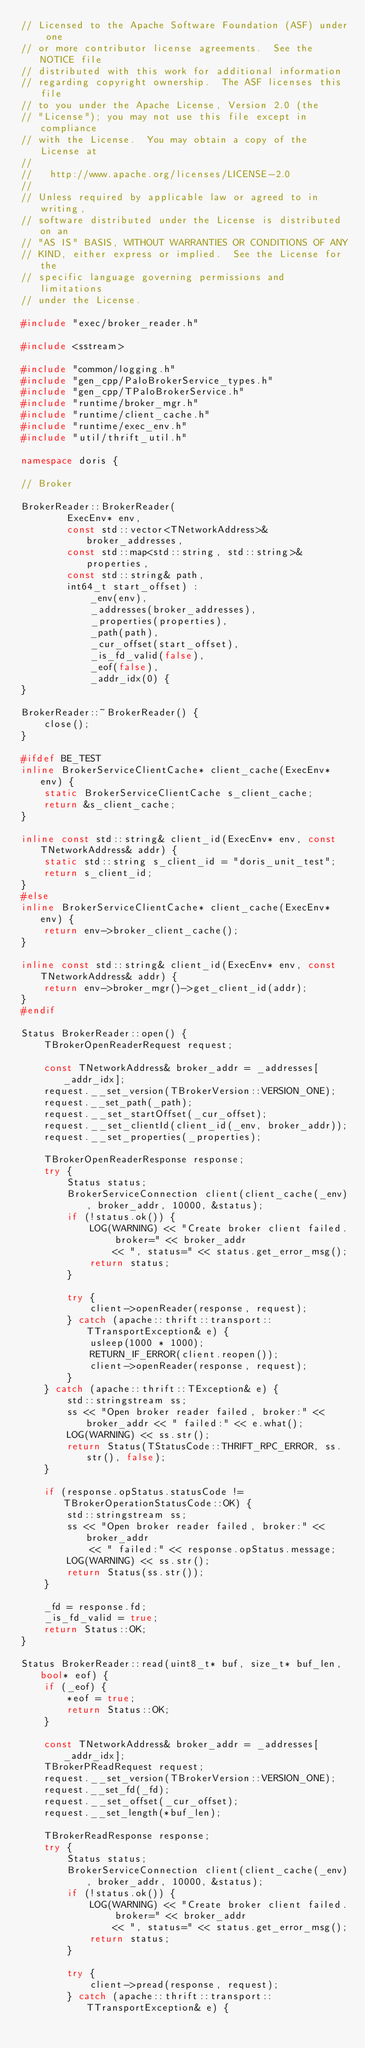Convert code to text. <code><loc_0><loc_0><loc_500><loc_500><_C++_>// Licensed to the Apache Software Foundation (ASF) under one
// or more contributor license agreements.  See the NOTICE file
// distributed with this work for additional information
// regarding copyright ownership.  The ASF licenses this file
// to you under the Apache License, Version 2.0 (the
// "License"); you may not use this file except in compliance
// with the License.  You may obtain a copy of the License at
//
//   http://www.apache.org/licenses/LICENSE-2.0
//
// Unless required by applicable law or agreed to in writing,
// software distributed under the License is distributed on an
// "AS IS" BASIS, WITHOUT WARRANTIES OR CONDITIONS OF ANY
// KIND, either express or implied.  See the License for the
// specific language governing permissions and limitations
// under the License.

#include "exec/broker_reader.h"

#include <sstream>

#include "common/logging.h"
#include "gen_cpp/PaloBrokerService_types.h"
#include "gen_cpp/TPaloBrokerService.h"
#include "runtime/broker_mgr.h"
#include "runtime/client_cache.h"
#include "runtime/exec_env.h"
#include "util/thrift_util.h"

namespace doris {

// Broker

BrokerReader::BrokerReader(
        ExecEnv* env,
        const std::vector<TNetworkAddress>& broker_addresses,
        const std::map<std::string, std::string>& properties,
        const std::string& path,
        int64_t start_offset) :
            _env(env),
            _addresses(broker_addresses),
            _properties(properties),
            _path(path),
            _cur_offset(start_offset),
            _is_fd_valid(false),
            _eof(false),
            _addr_idx(0) {
}

BrokerReader::~BrokerReader() {
    close();
}

#ifdef BE_TEST
inline BrokerServiceClientCache* client_cache(ExecEnv* env) {
    static BrokerServiceClientCache s_client_cache;
    return &s_client_cache;
}

inline const std::string& client_id(ExecEnv* env, const TNetworkAddress& addr) {
    static std::string s_client_id = "doris_unit_test";
    return s_client_id;
}
#else
inline BrokerServiceClientCache* client_cache(ExecEnv* env) {
    return env->broker_client_cache();
}

inline const std::string& client_id(ExecEnv* env, const TNetworkAddress& addr) {
    return env->broker_mgr()->get_client_id(addr);
}
#endif

Status BrokerReader::open() {
    TBrokerOpenReaderRequest request;

    const TNetworkAddress& broker_addr = _addresses[_addr_idx];
    request.__set_version(TBrokerVersion::VERSION_ONE);
    request.__set_path(_path);
    request.__set_startOffset(_cur_offset);
    request.__set_clientId(client_id(_env, broker_addr));
    request.__set_properties(_properties);

    TBrokerOpenReaderResponse response;
    try {
        Status status;
        BrokerServiceConnection client(client_cache(_env), broker_addr, 10000, &status);
        if (!status.ok()) {
            LOG(WARNING) << "Create broker client failed. broker=" << broker_addr
                << ", status=" << status.get_error_msg();
            return status;
        }

        try {
            client->openReader(response, request);
        } catch (apache::thrift::transport::TTransportException& e) {
            usleep(1000 * 1000);
            RETURN_IF_ERROR(client.reopen());
            client->openReader(response, request);
        }
    } catch (apache::thrift::TException& e) {
        std::stringstream ss;
        ss << "Open broker reader failed, broker:" << broker_addr << " failed:" << e.what();
        LOG(WARNING) << ss.str();
        return Status(TStatusCode::THRIFT_RPC_ERROR, ss.str(), false);
    }

    if (response.opStatus.statusCode != TBrokerOperationStatusCode::OK) {
        std::stringstream ss;
        ss << "Open broker reader failed, broker:" << broker_addr 
            << " failed:" << response.opStatus.message;
        LOG(WARNING) << ss.str();
        return Status(ss.str());
    }

    _fd = response.fd;
    _is_fd_valid = true;
    return Status::OK;
}

Status BrokerReader::read(uint8_t* buf, size_t* buf_len, bool* eof) {
    if (_eof) {
        *eof = true;
        return Status::OK;
    }
    
    const TNetworkAddress& broker_addr = _addresses[_addr_idx];
    TBrokerPReadRequest request;
    request.__set_version(TBrokerVersion::VERSION_ONE);
    request.__set_fd(_fd);
    request.__set_offset(_cur_offset);
    request.__set_length(*buf_len);

    TBrokerReadResponse response;
    try {
        Status status;
        BrokerServiceConnection client(client_cache(_env), broker_addr, 10000, &status);
        if (!status.ok()) {
            LOG(WARNING) << "Create broker client failed. broker=" << broker_addr
                << ", status=" << status.get_error_msg();
            return status;
        }

        try {
            client->pread(response, request);
        } catch (apache::thrift::transport::TTransportException& e) {</code> 